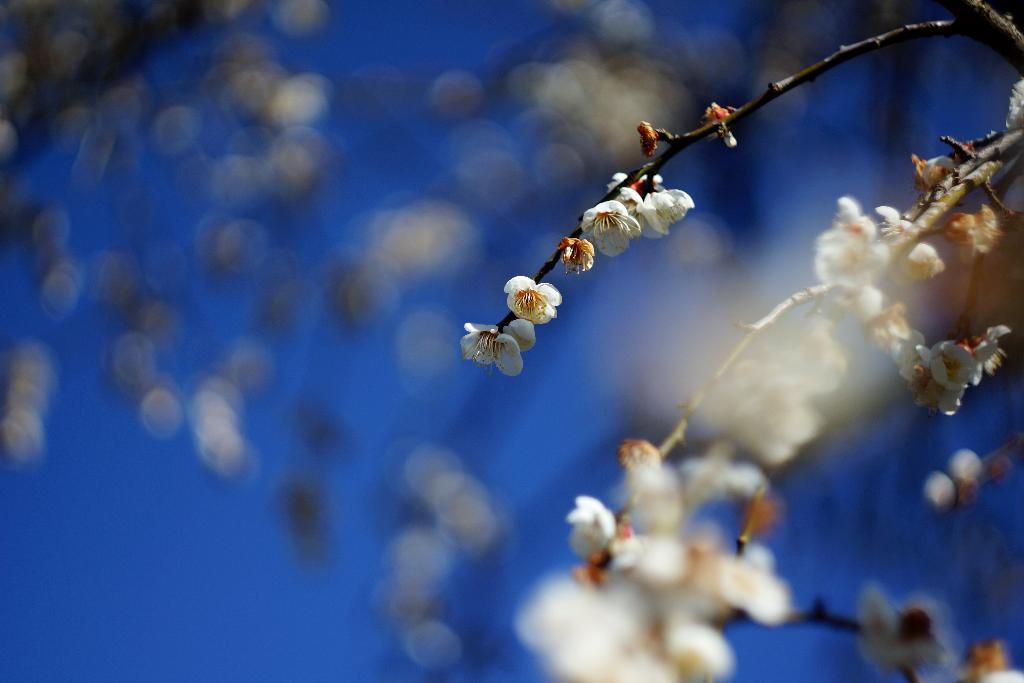What is in the foreground of the image? There are flowers in the foreground of the image. What can be seen in the background of the image? There is sky visible in the background of the image. Are there any other flowers in the image besides those in the foreground? Yes, there are more flowers in the background of the image. What type of powder is being used to enhance the growth of the flowers in the image? There is no mention of any powder or growth enhancement in the image; it simply features flowers in the foreground and background. 